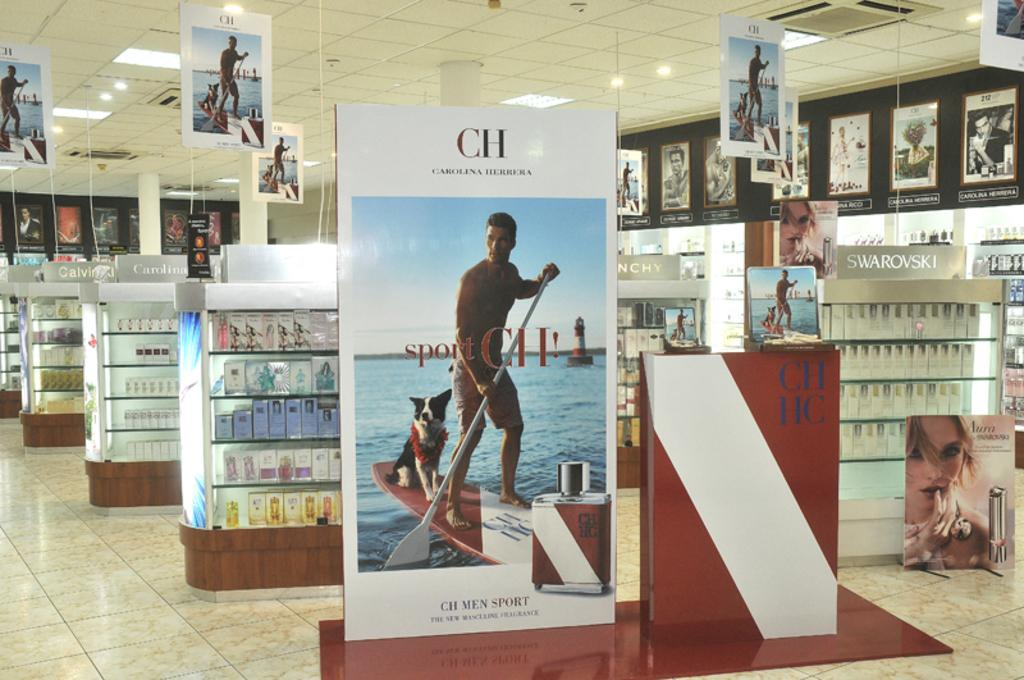<image>
Share a concise interpretation of the image provided. an advertisement for carolina hererra's men sport cologne 